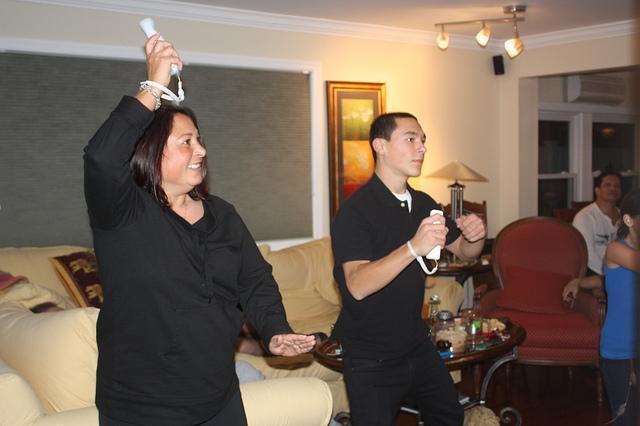The relationship between these people is most likely what?
Make your selection and explain in format: 'Answer: answer
Rationale: rationale.'
Options: Enemies, coworkers, strangers, family. Answer: family.
Rationale: They seems they are having fun as they are a family. 